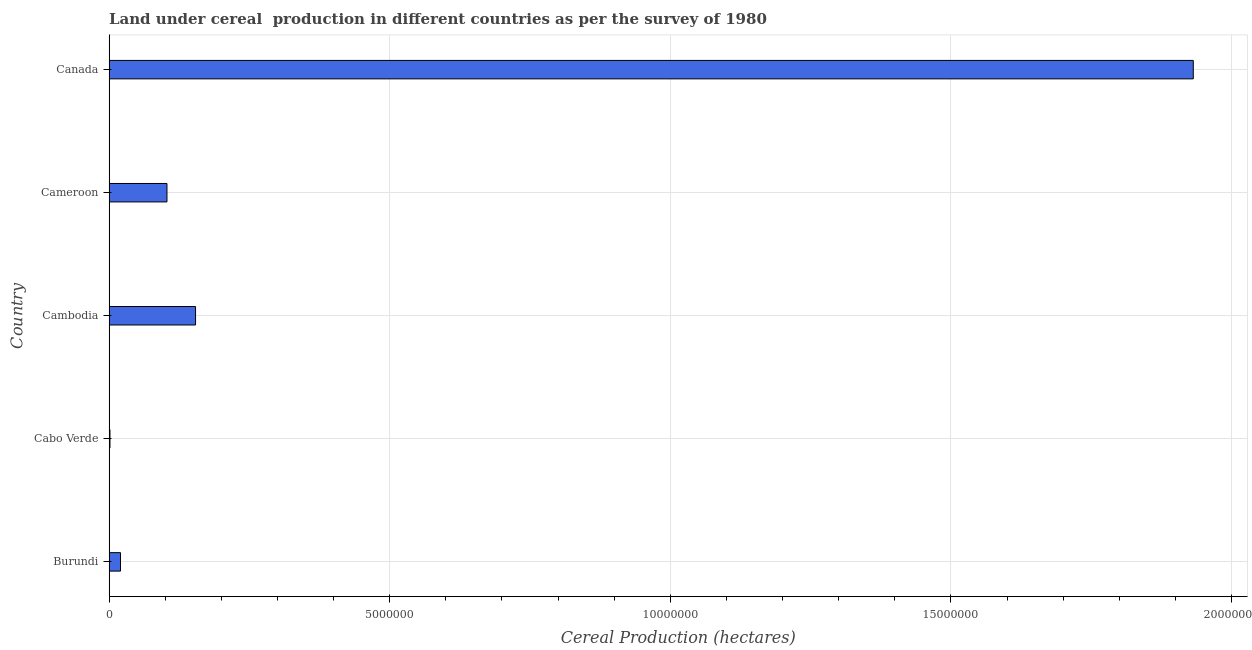Does the graph contain any zero values?
Your answer should be compact. No. Does the graph contain grids?
Make the answer very short. Yes. What is the title of the graph?
Ensure brevity in your answer.  Land under cereal  production in different countries as per the survey of 1980. What is the label or title of the X-axis?
Your answer should be very brief. Cereal Production (hectares). What is the label or title of the Y-axis?
Make the answer very short. Country. What is the land under cereal production in Cambodia?
Make the answer very short. 1.54e+06. Across all countries, what is the maximum land under cereal production?
Provide a succinct answer. 1.93e+07. Across all countries, what is the minimum land under cereal production?
Give a very brief answer. 1.60e+04. In which country was the land under cereal production minimum?
Your response must be concise. Cabo Verde. What is the sum of the land under cereal production?
Ensure brevity in your answer.  2.21e+07. What is the difference between the land under cereal production in Cabo Verde and Canada?
Your response must be concise. -1.93e+07. What is the average land under cereal production per country?
Keep it short and to the point. 4.42e+06. What is the median land under cereal production?
Ensure brevity in your answer.  1.03e+06. Is the difference between the land under cereal production in Cameroon and Canada greater than the difference between any two countries?
Ensure brevity in your answer.  No. What is the difference between the highest and the second highest land under cereal production?
Your answer should be very brief. 1.78e+07. Is the sum of the land under cereal production in Burundi and Canada greater than the maximum land under cereal production across all countries?
Your answer should be compact. Yes. What is the difference between the highest and the lowest land under cereal production?
Offer a very short reply. 1.93e+07. How many bars are there?
Provide a short and direct response. 5. Are the values on the major ticks of X-axis written in scientific E-notation?
Provide a succinct answer. No. What is the Cereal Production (hectares) of Burundi?
Your answer should be very brief. 2.04e+05. What is the Cereal Production (hectares) in Cabo Verde?
Give a very brief answer. 1.60e+04. What is the Cereal Production (hectares) in Cambodia?
Give a very brief answer. 1.54e+06. What is the Cereal Production (hectares) in Cameroon?
Your response must be concise. 1.03e+06. What is the Cereal Production (hectares) of Canada?
Offer a terse response. 1.93e+07. What is the difference between the Cereal Production (hectares) in Burundi and Cabo Verde?
Ensure brevity in your answer.  1.88e+05. What is the difference between the Cereal Production (hectares) in Burundi and Cambodia?
Provide a short and direct response. -1.34e+06. What is the difference between the Cereal Production (hectares) in Burundi and Cameroon?
Your answer should be compact. -8.28e+05. What is the difference between the Cereal Production (hectares) in Burundi and Canada?
Your answer should be very brief. -1.91e+07. What is the difference between the Cereal Production (hectares) in Cabo Verde and Cambodia?
Offer a terse response. -1.52e+06. What is the difference between the Cereal Production (hectares) in Cabo Verde and Cameroon?
Offer a very short reply. -1.02e+06. What is the difference between the Cereal Production (hectares) in Cabo Verde and Canada?
Provide a succinct answer. -1.93e+07. What is the difference between the Cereal Production (hectares) in Cambodia and Cameroon?
Keep it short and to the point. 5.09e+05. What is the difference between the Cereal Production (hectares) in Cambodia and Canada?
Your answer should be compact. -1.78e+07. What is the difference between the Cereal Production (hectares) in Cameroon and Canada?
Give a very brief answer. -1.83e+07. What is the ratio of the Cereal Production (hectares) in Burundi to that in Cabo Verde?
Ensure brevity in your answer.  12.73. What is the ratio of the Cereal Production (hectares) in Burundi to that in Cambodia?
Your response must be concise. 0.13. What is the ratio of the Cereal Production (hectares) in Burundi to that in Cameroon?
Your answer should be very brief. 0.2. What is the ratio of the Cereal Production (hectares) in Burundi to that in Canada?
Give a very brief answer. 0.01. What is the ratio of the Cereal Production (hectares) in Cabo Verde to that in Cameroon?
Make the answer very short. 0.02. What is the ratio of the Cereal Production (hectares) in Cabo Verde to that in Canada?
Your answer should be very brief. 0. What is the ratio of the Cereal Production (hectares) in Cambodia to that in Cameroon?
Ensure brevity in your answer.  1.49. What is the ratio of the Cereal Production (hectares) in Cambodia to that in Canada?
Provide a succinct answer. 0.08. What is the ratio of the Cereal Production (hectares) in Cameroon to that in Canada?
Your answer should be compact. 0.05. 